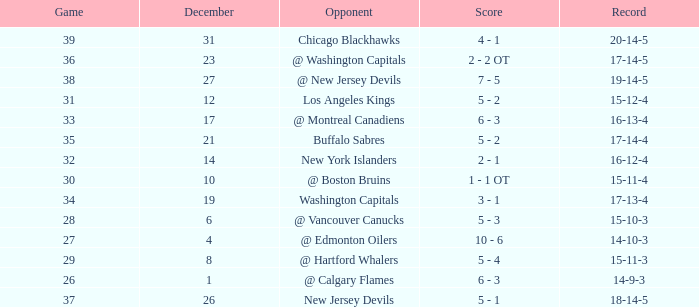Game smaller than 34, and a December smaller than 14, and a Score of 10 - 6 has what opponent? @ Edmonton Oilers. 